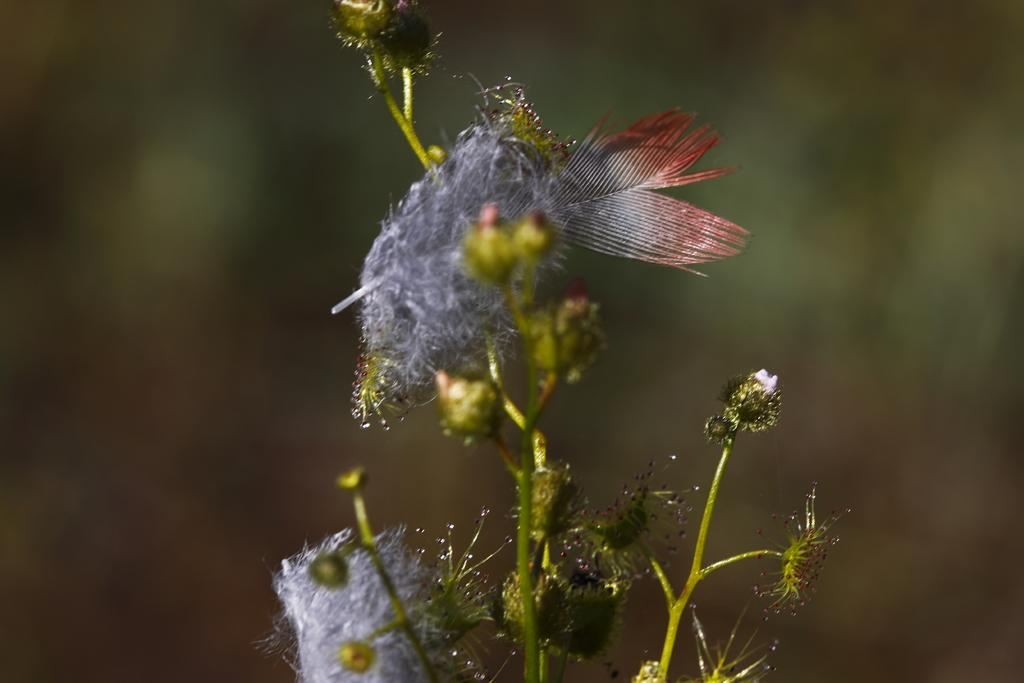What is the main subject of the image? The main subject of the image is a stem. What is attached to the stem? There are flowers attached to the stem in the image. Can you describe the color of an object in the image? Yes, there is a grey color object in the image. How would you describe the background of the image? The background of the image is blurry. What type of badge can be seen hanging from the stem in the image? There is no badge present in the image; it features a stem with flowers. How many planes are visible in the image? There are no planes visible in the image. --- Facts: 1. There is a person in the image. 2. The person is wearing a hat. 3. The person is holding a book. 4. There is a table in the image. 5. The table has a lamp on it. Absurd Topics: elephant, ocean, bicycle Conversation: What is the main subject of the image? The main subject of the image is a person. What is the person wearing in the image? The person is wearing a hat in the image. What is the person holding in the image? The person is holding a book in the image. What piece of furniture is present in the image? There is a table in the image. What object is on the table in the image? The table has a lamp on it in the image. Reasoning: Let's think step by step in order to produce the conversation. We start by identifying the main subject of the image, which is the person. Then, we describe what the person is wearing and holding, which are a hat and a book, respectively. Next, we mention the presence of a table in the image. Finally, we describe the object on the table, which is a lamp. Absurd Question/Answer: Can you tell me how many elephants are swimming in the ocean in the image? There are no elephants or ocean present in the image; it features a person wearing a hat and holding a book, with a table and lamp nearby. What type of bicycle is leaning against the table in the image? There is no bicycle present in the image. --- Facts: 1. There is a person in the image. 2. The person is holding a guitar. 3. The person is standing on a stage. 4. There are speakers on the stage. 5. The background of the image is dark. Absurd Topics: snow, umbrella, cake Conversation: What is the main subject of the image? The main subject of the image is a person. What is the person holding in the image? The person is holding a guitar in the image. Where is the person located in the image? The person is standing 